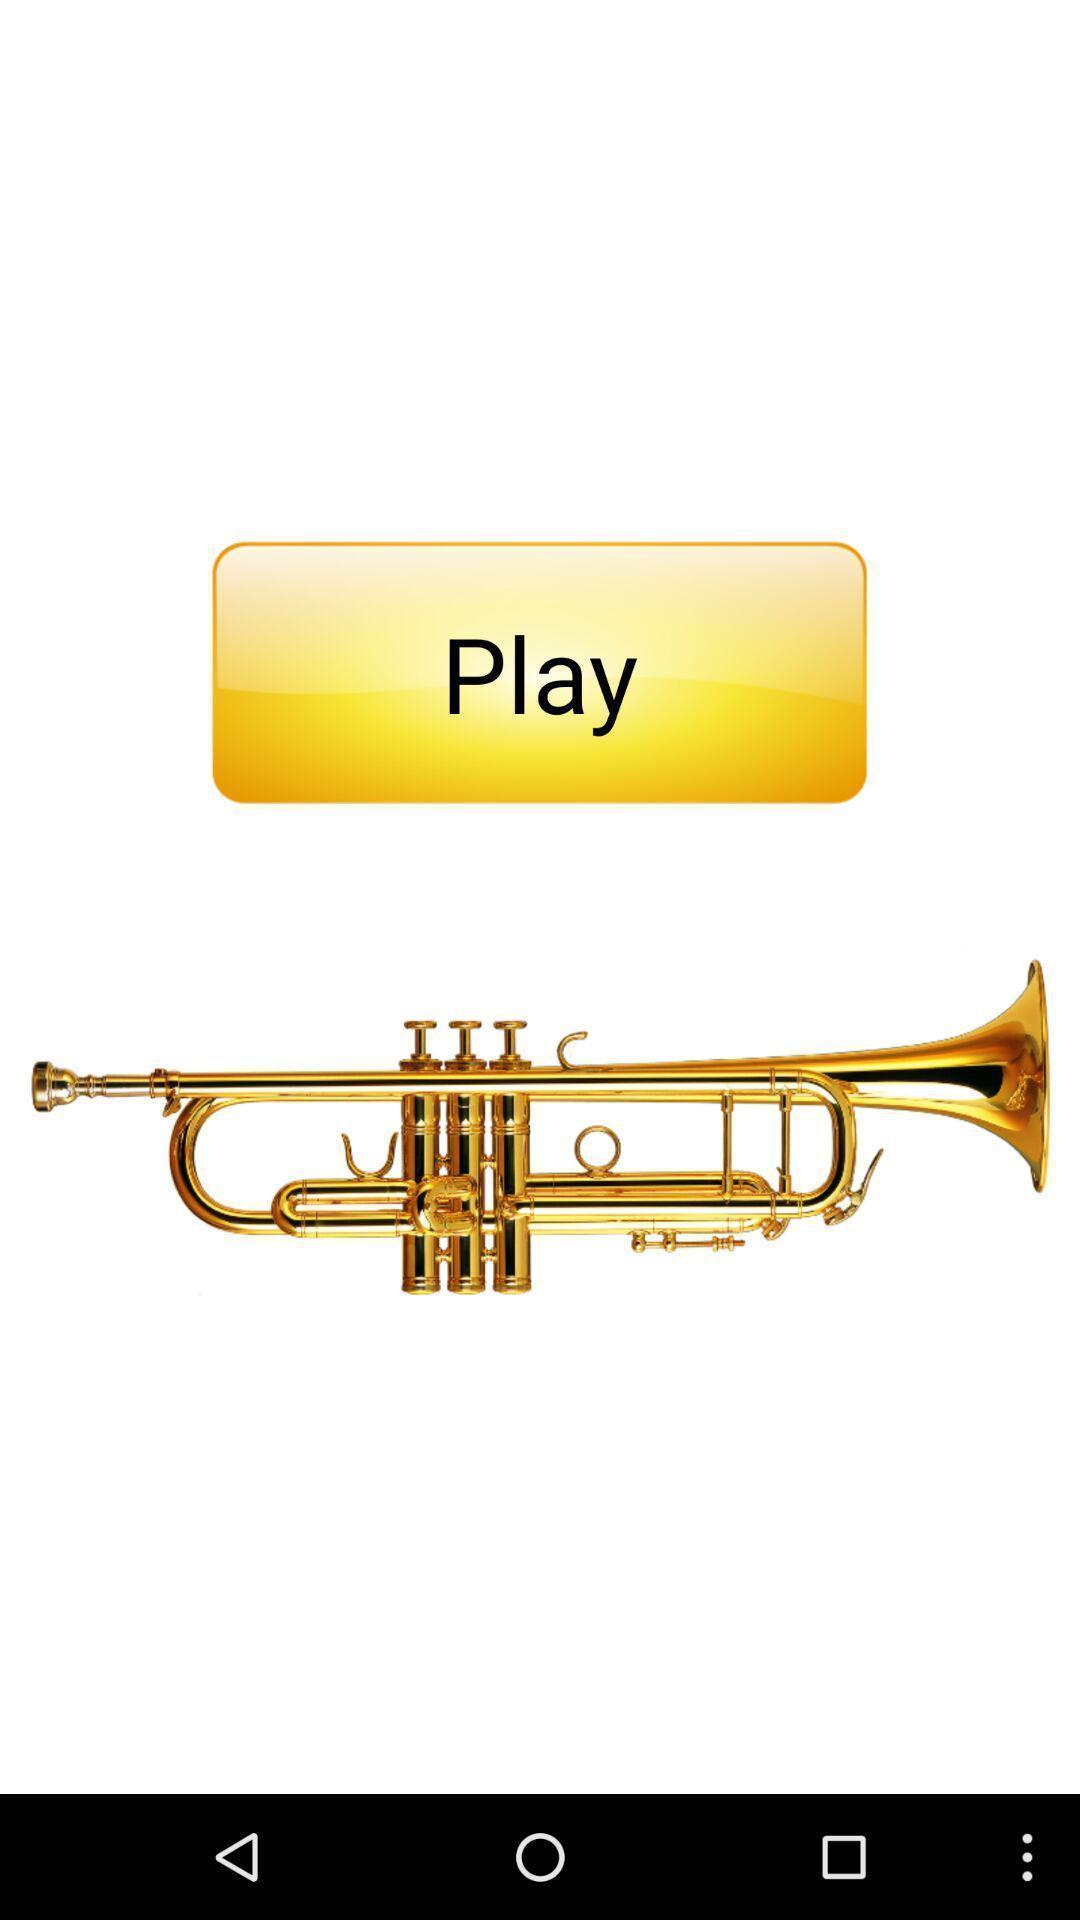Provide a description of this screenshot. Page displaying musical instrument. 